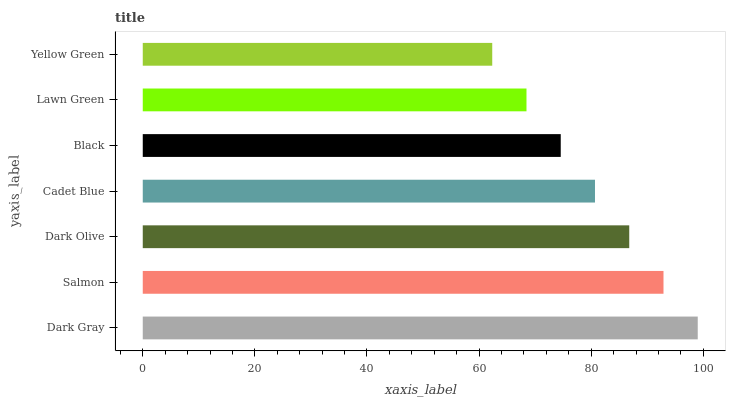Is Yellow Green the minimum?
Answer yes or no. Yes. Is Dark Gray the maximum?
Answer yes or no. Yes. Is Salmon the minimum?
Answer yes or no. No. Is Salmon the maximum?
Answer yes or no. No. Is Dark Gray greater than Salmon?
Answer yes or no. Yes. Is Salmon less than Dark Gray?
Answer yes or no. Yes. Is Salmon greater than Dark Gray?
Answer yes or no. No. Is Dark Gray less than Salmon?
Answer yes or no. No. Is Cadet Blue the high median?
Answer yes or no. Yes. Is Cadet Blue the low median?
Answer yes or no. Yes. Is Dark Gray the high median?
Answer yes or no. No. Is Salmon the low median?
Answer yes or no. No. 